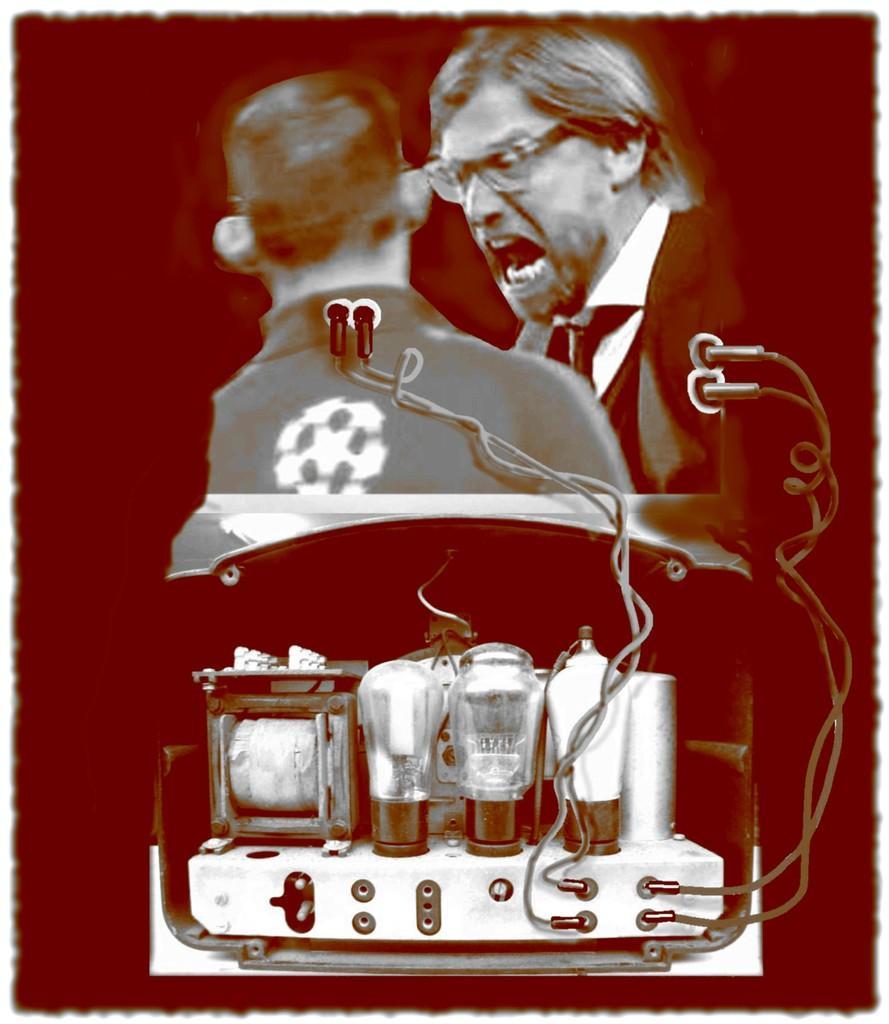Please provide a concise description of this image. In this image we can see the electrical instruments. And we can see two people in the animated image. And we can see the dark background. 